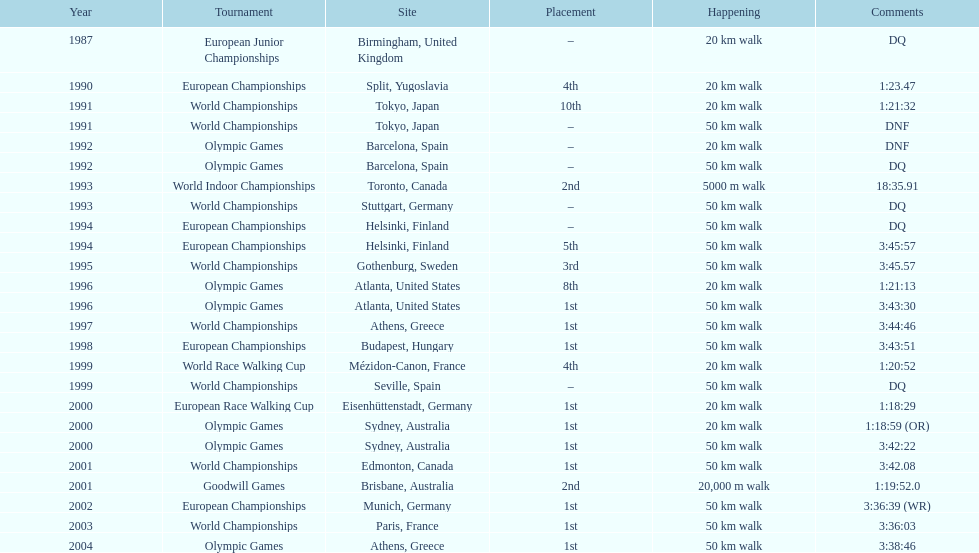How many times did korzeniowski finish above fourth place? 13. 